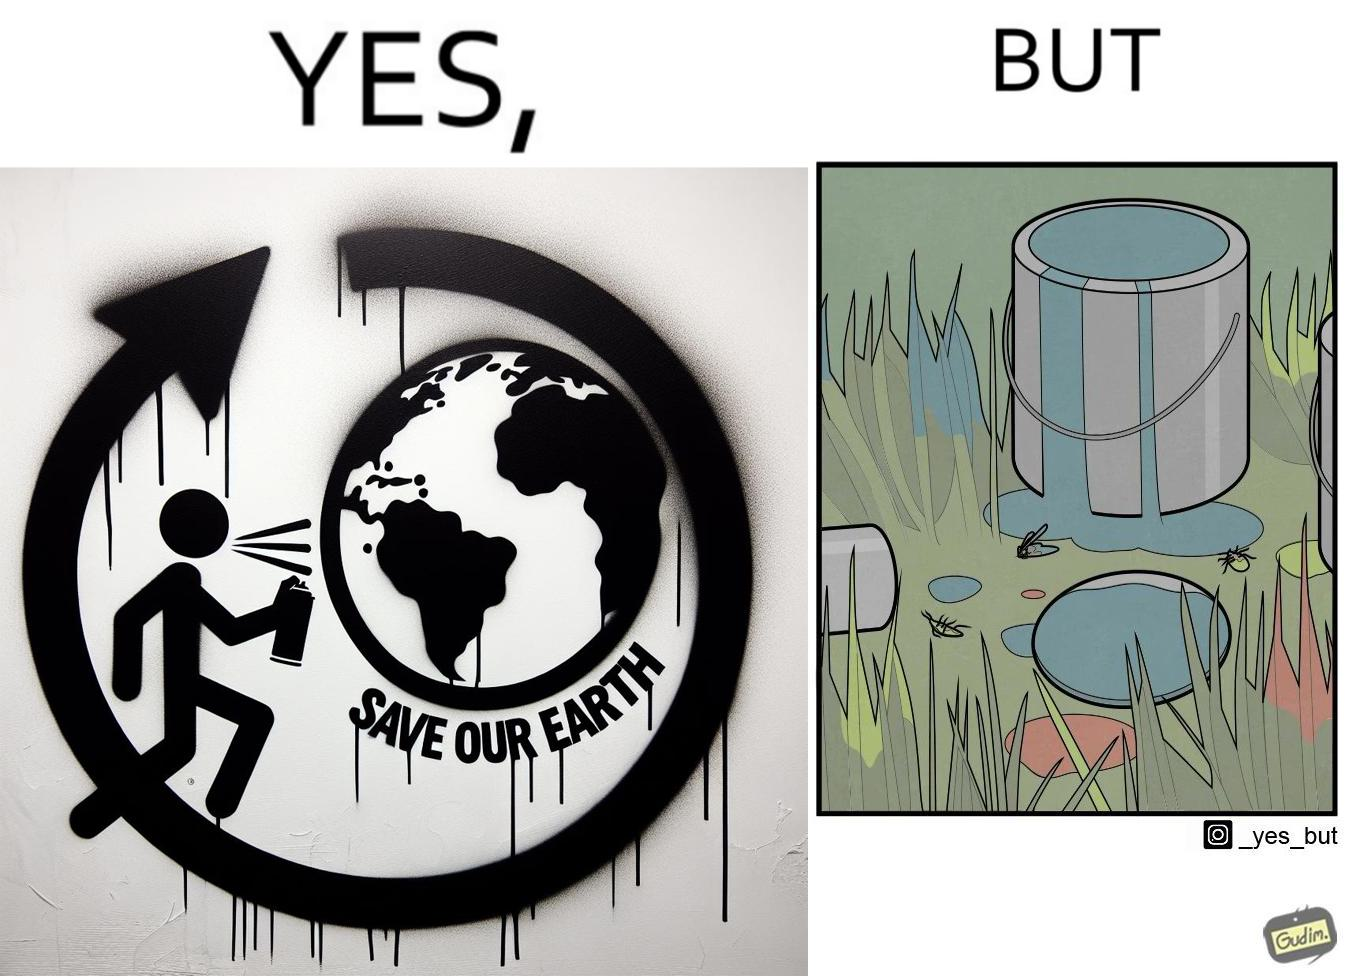What is shown in the left half versus the right half of this image? In the left part of the image: A man drawing a graffiti themed "save Our earth". In the right part of the image: A can of paint, overflowing onto the grass. The paint seems to be harmful for insects. 